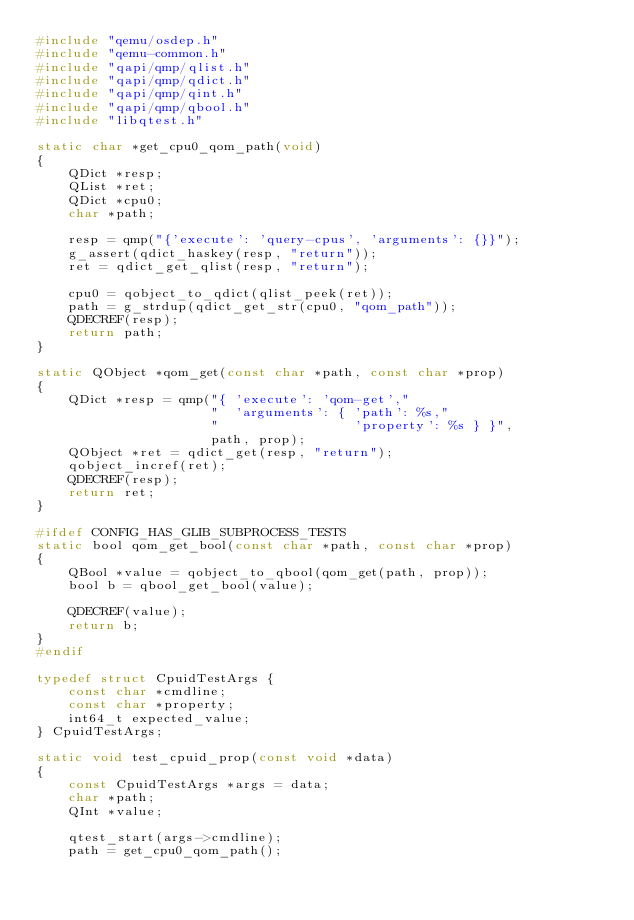Convert code to text. <code><loc_0><loc_0><loc_500><loc_500><_C_>#include "qemu/osdep.h"
#include "qemu-common.h"
#include "qapi/qmp/qlist.h"
#include "qapi/qmp/qdict.h"
#include "qapi/qmp/qint.h"
#include "qapi/qmp/qbool.h"
#include "libqtest.h"

static char *get_cpu0_qom_path(void)
{
    QDict *resp;
    QList *ret;
    QDict *cpu0;
    char *path;

    resp = qmp("{'execute': 'query-cpus', 'arguments': {}}");
    g_assert(qdict_haskey(resp, "return"));
    ret = qdict_get_qlist(resp, "return");

    cpu0 = qobject_to_qdict(qlist_peek(ret));
    path = g_strdup(qdict_get_str(cpu0, "qom_path"));
    QDECREF(resp);
    return path;
}

static QObject *qom_get(const char *path, const char *prop)
{
    QDict *resp = qmp("{ 'execute': 'qom-get',"
                      "  'arguments': { 'path': %s,"
                      "                 'property': %s } }",
                      path, prop);
    QObject *ret = qdict_get(resp, "return");
    qobject_incref(ret);
    QDECREF(resp);
    return ret;
}

#ifdef CONFIG_HAS_GLIB_SUBPROCESS_TESTS
static bool qom_get_bool(const char *path, const char *prop)
{
    QBool *value = qobject_to_qbool(qom_get(path, prop));
    bool b = qbool_get_bool(value);

    QDECREF(value);
    return b;
}
#endif

typedef struct CpuidTestArgs {
    const char *cmdline;
    const char *property;
    int64_t expected_value;
} CpuidTestArgs;

static void test_cpuid_prop(const void *data)
{
    const CpuidTestArgs *args = data;
    char *path;
    QInt *value;

    qtest_start(args->cmdline);
    path = get_cpu0_qom_path();</code> 